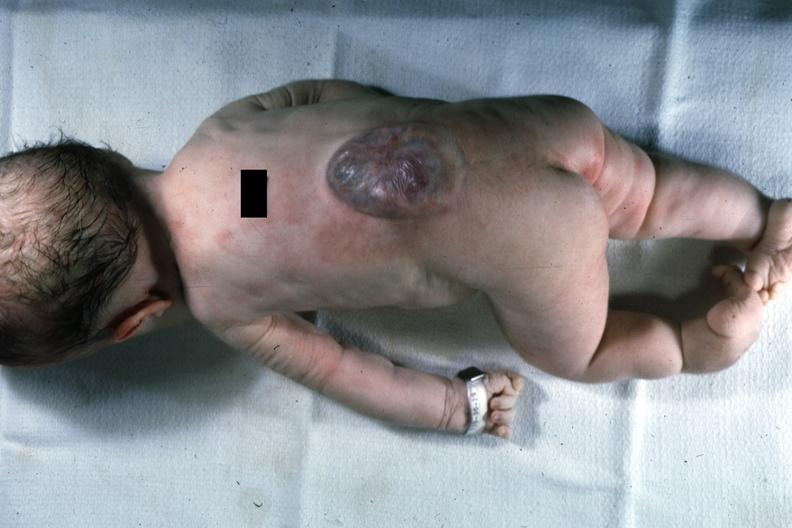what does this photo of infant from head to toe show?
Answer the question using a single word or phrase. Typical lesion 